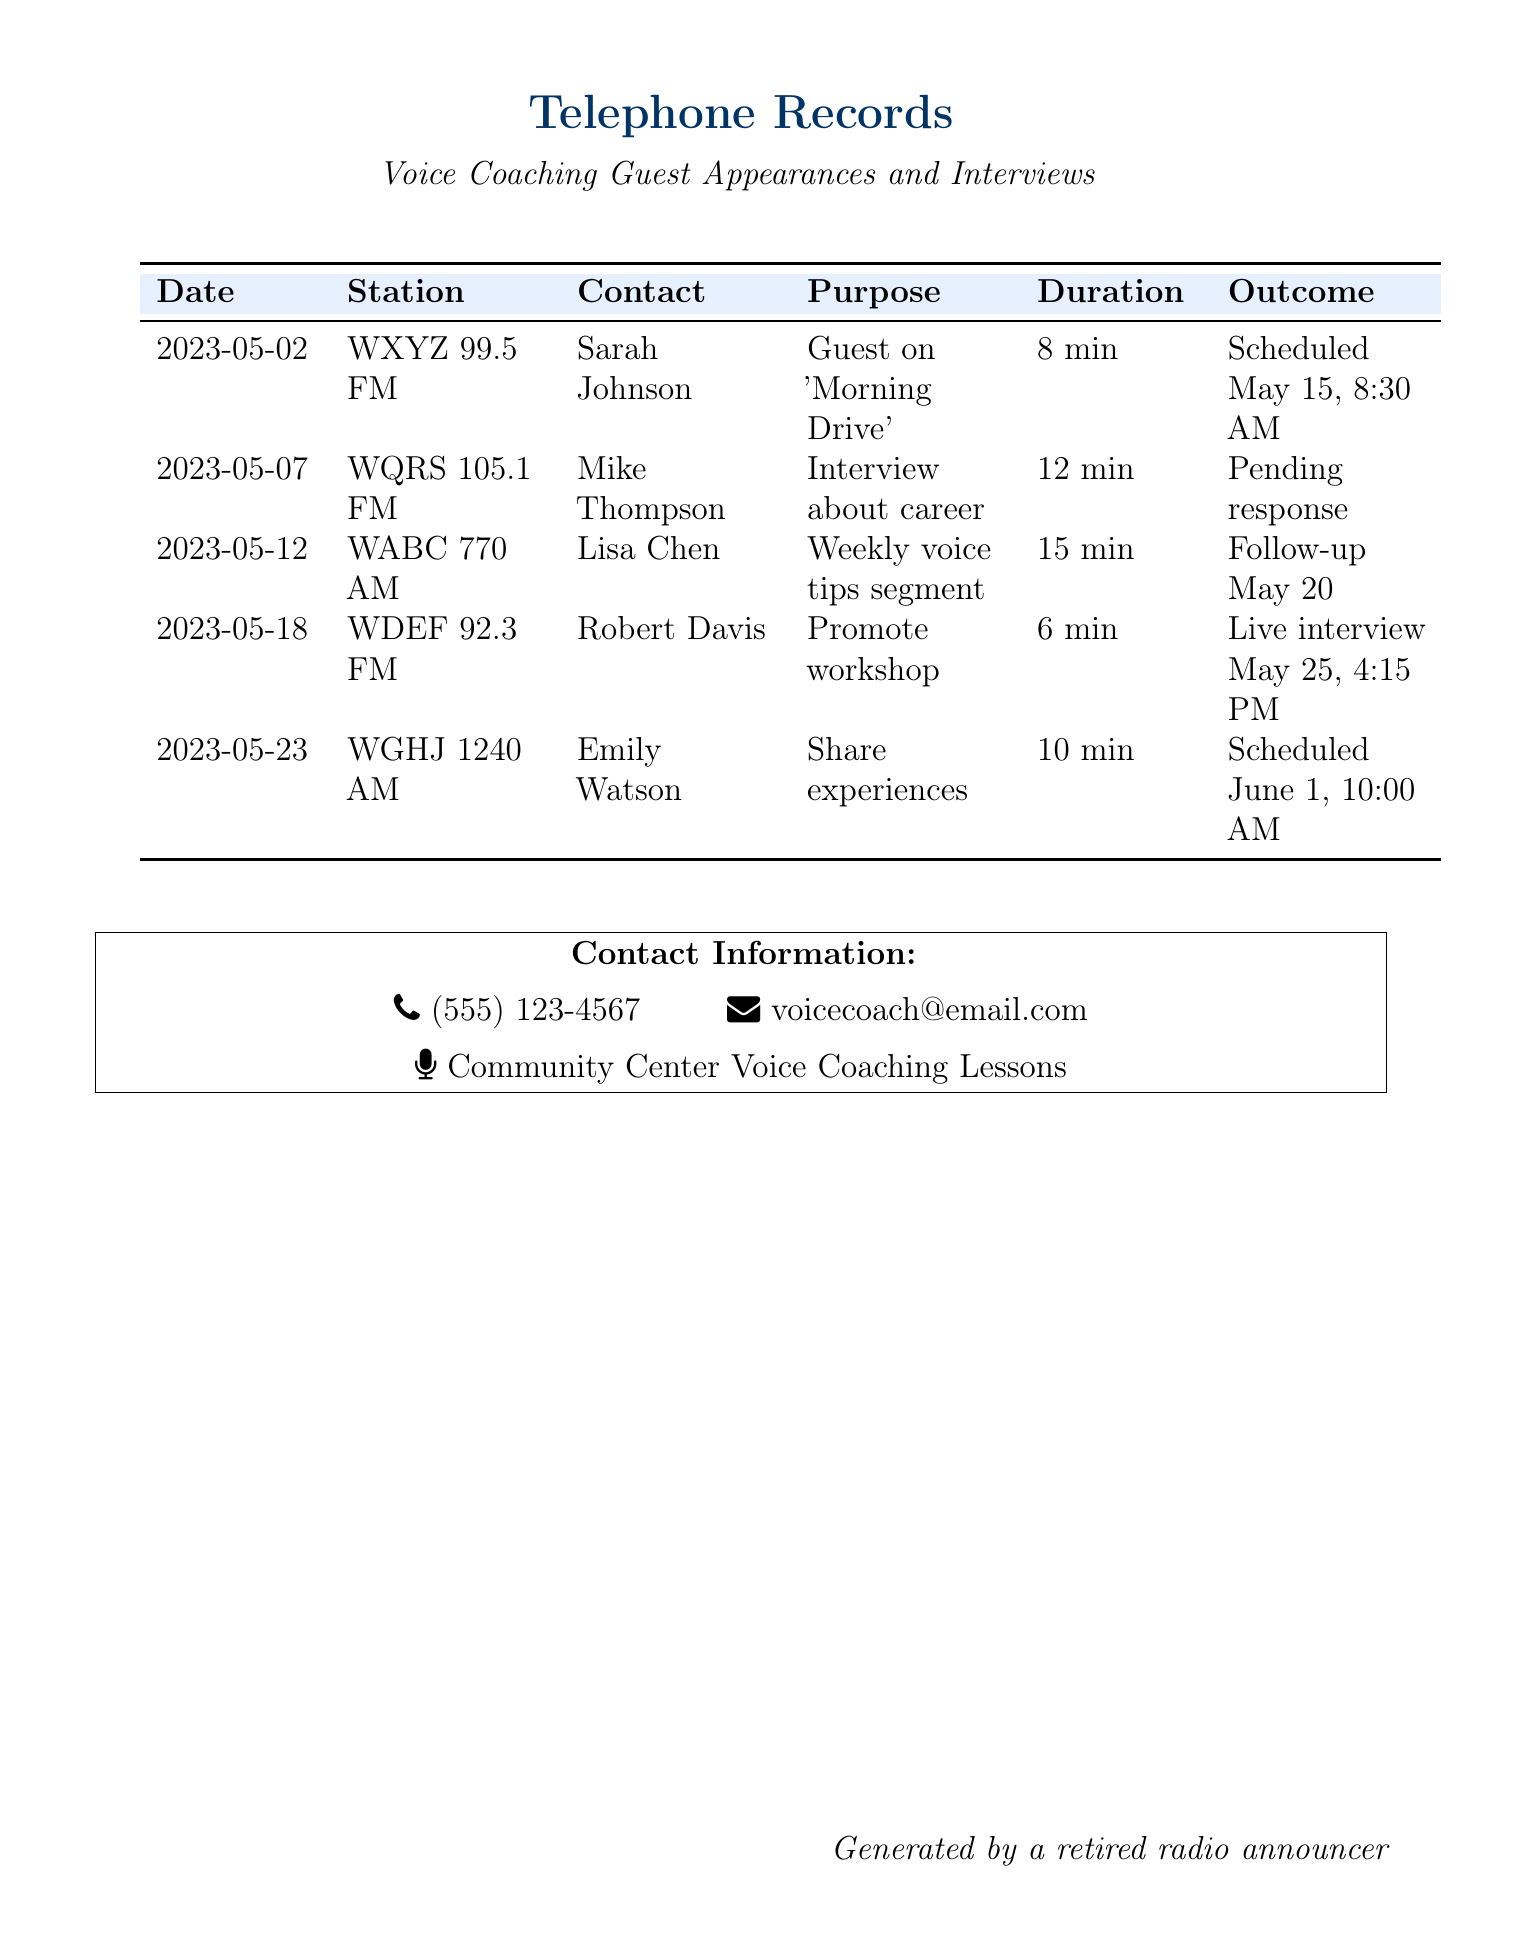What is the date of the first call? The first call listed in the records is on May 2, 2023.
Answer: May 2, 2023 Who is the contact at WDEF 92.3 FM? The contact for WDEF 92.3 FM is Robert Davis.
Answer: Robert Davis What was the purpose of the call on May 12? The purpose of the call on May 12 was for a weekly voice tips segment.
Answer: Weekly voice tips segment How many minutes was the interview about the career? The duration of the interview about the career was 12 minutes.
Answer: 12 min On what date is the live interview scheduled? The live interview is scheduled for May 25.
Answer: May 25 Which station has a follow-up scheduled for May 20? WABC 770 AM has a follow-up scheduled for May 20.
Answer: WABC 770 AM What is the outcome of the call to WQRS 105.1 FM? The outcome of the call to WQRS 105.1 FM is pending response.
Answer: Pending response How many calls are scheduled after May 18? There are two calls scheduled after May 18.
Answer: 2 What type of document is this? This document is a telephone records log.
Answer: Telephone records 